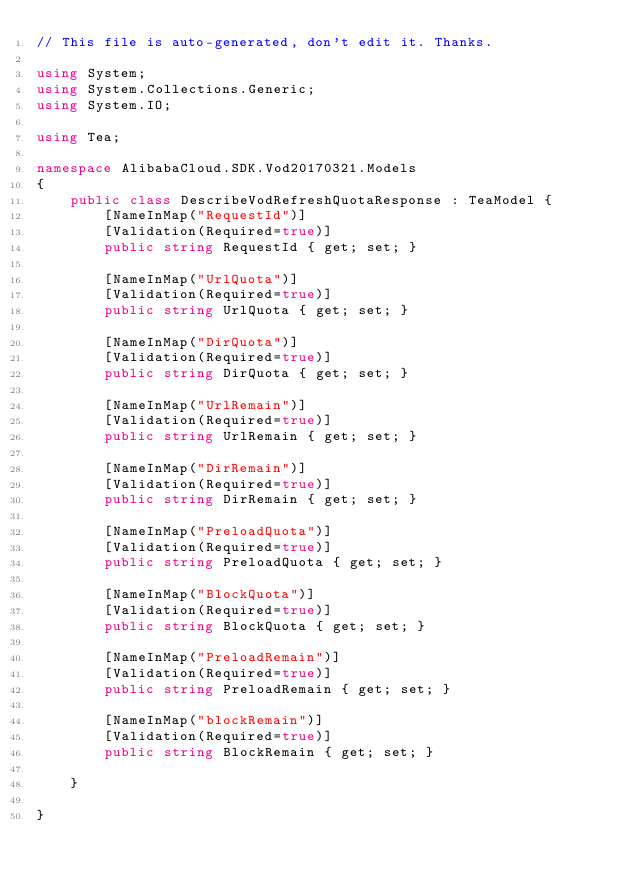Convert code to text. <code><loc_0><loc_0><loc_500><loc_500><_C#_>// This file is auto-generated, don't edit it. Thanks.

using System;
using System.Collections.Generic;
using System.IO;

using Tea;

namespace AlibabaCloud.SDK.Vod20170321.Models
{
    public class DescribeVodRefreshQuotaResponse : TeaModel {
        [NameInMap("RequestId")]
        [Validation(Required=true)]
        public string RequestId { get; set; }

        [NameInMap("UrlQuota")]
        [Validation(Required=true)]
        public string UrlQuota { get; set; }

        [NameInMap("DirQuota")]
        [Validation(Required=true)]
        public string DirQuota { get; set; }

        [NameInMap("UrlRemain")]
        [Validation(Required=true)]
        public string UrlRemain { get; set; }

        [NameInMap("DirRemain")]
        [Validation(Required=true)]
        public string DirRemain { get; set; }

        [NameInMap("PreloadQuota")]
        [Validation(Required=true)]
        public string PreloadQuota { get; set; }

        [NameInMap("BlockQuota")]
        [Validation(Required=true)]
        public string BlockQuota { get; set; }

        [NameInMap("PreloadRemain")]
        [Validation(Required=true)]
        public string PreloadRemain { get; set; }

        [NameInMap("blockRemain")]
        [Validation(Required=true)]
        public string BlockRemain { get; set; }

    }

}
</code> 